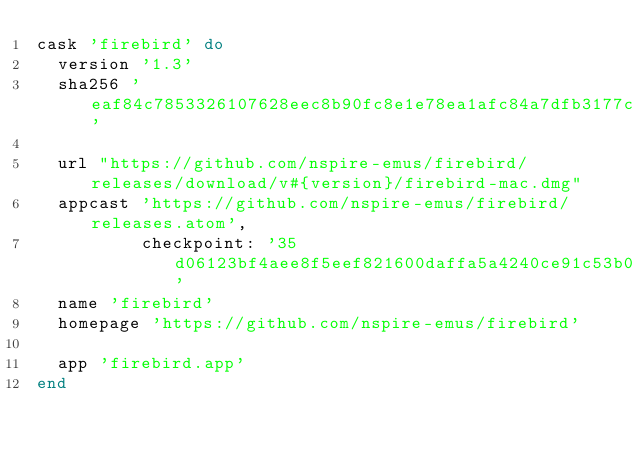Convert code to text. <code><loc_0><loc_0><loc_500><loc_500><_Ruby_>cask 'firebird' do
  version '1.3'
  sha256 'eaf84c7853326107628eec8b90fc8e1e78ea1afc84a7dfb3177ca50c273b7250'

  url "https://github.com/nspire-emus/firebird/releases/download/v#{version}/firebird-mac.dmg"
  appcast 'https://github.com/nspire-emus/firebird/releases.atom',
          checkpoint: '35d06123bf4aee8f5eef821600daffa5a4240ce91c53b07fe2577e827249ddf8'
  name 'firebird'
  homepage 'https://github.com/nspire-emus/firebird'

  app 'firebird.app'
end
</code> 